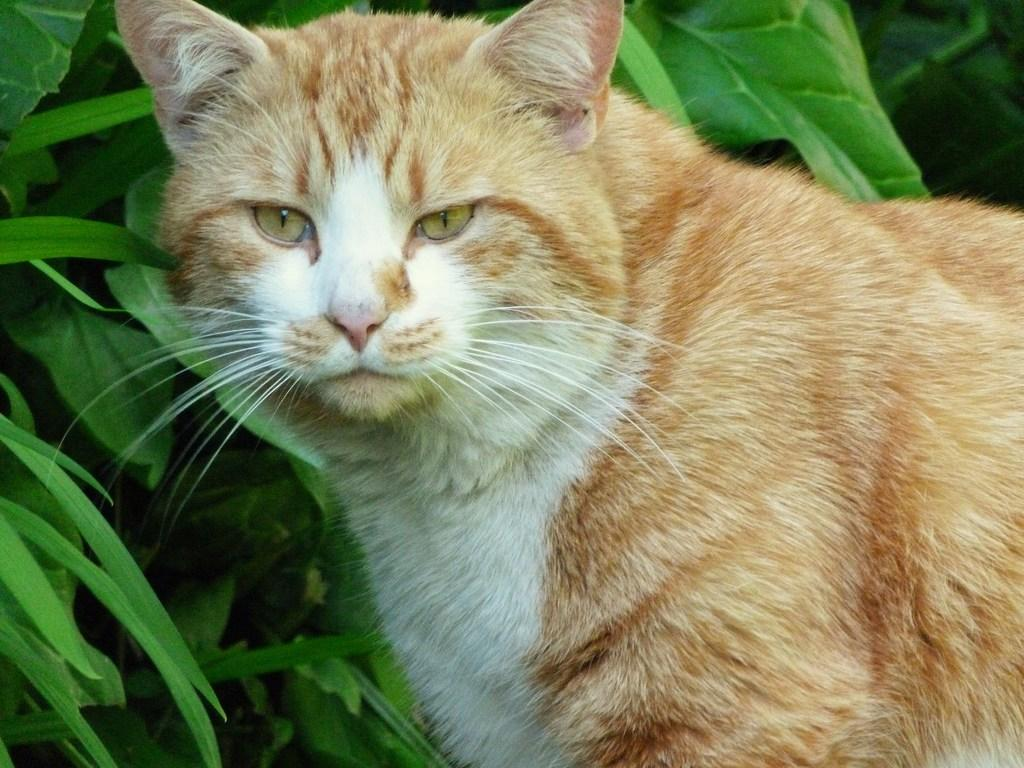What type of animal is in the image? There is a cat in the image. How is the cat positioned in the image? The cat is truncated towards the right of the image. What can be seen in the background of the image? There are plants in the background of the image. How are the plants depicted in the image? The plants are truncated. Can you see a cake being jumped over by a hen in the image? No, there is no cake or hen present in the image. 